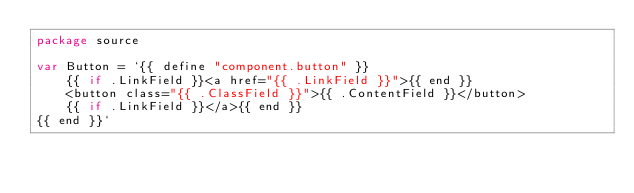Convert code to text. <code><loc_0><loc_0><loc_500><loc_500><_Go_>package source

var Button = `{{ define "component.button" }}
    {{ if .LinkField }}<a href="{{ .LinkField }}">{{ end }}
    <button class="{{ .ClassField }}">{{ .ContentField }}</button>
    {{ if .LinkField }}</a>{{ end }}
{{ end }}`
</code> 